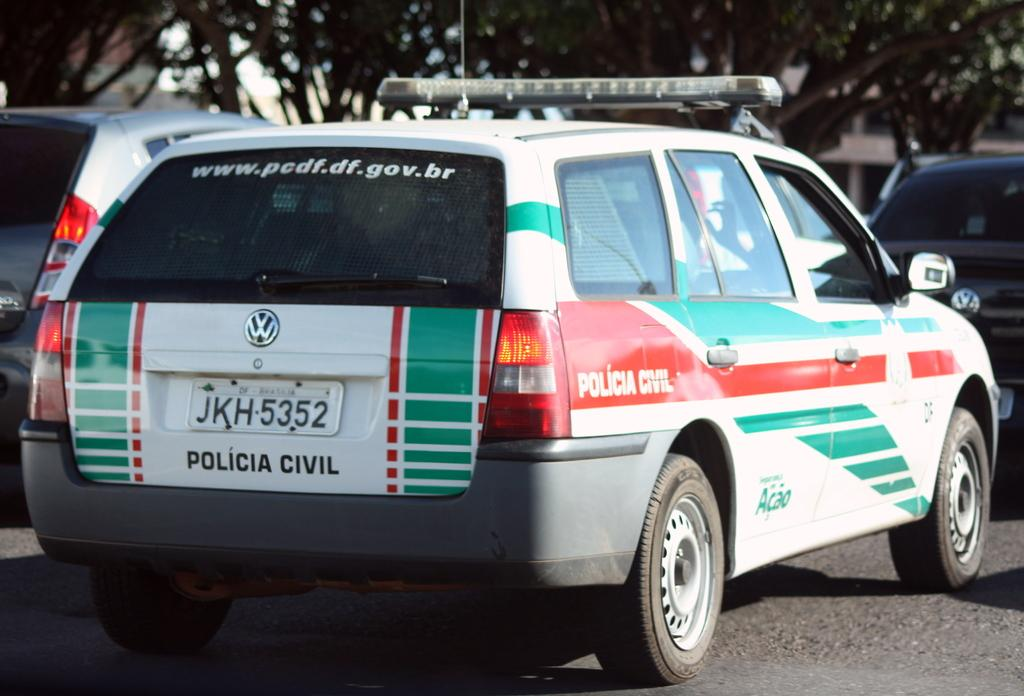What type of vehicles can be seen on the road in the image? There are cars on the road in the image. What else can be seen in the image besides the cars? There are trees visible in the image. How many minutes does it take for the room to be cleaned in the image? There is no room present in the image, so it is not possible to determine how long it takes to clean it. 